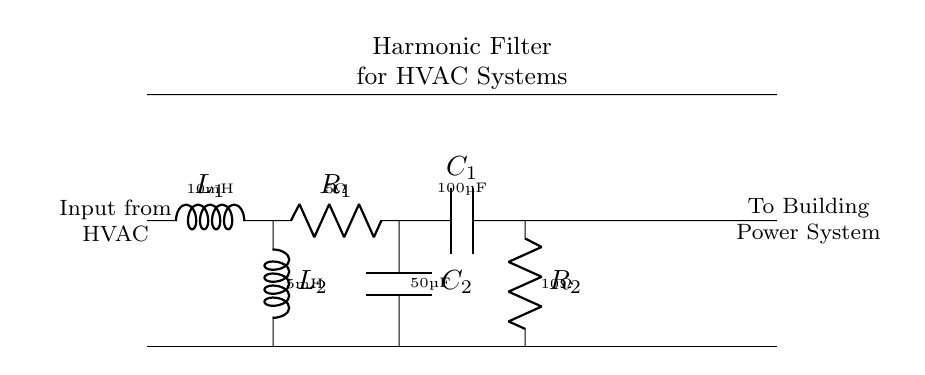What components are in the circuit? The components in the circuit include two inductors, two capacitors, and two resistors. They are labeled as L1, L2, C1, C2, R1, and R2.
Answer: Two inductors, two capacitors, two resistors What is the value of the first capacitor? The value of the first capacitor is indicated next to C1 in the diagram, which is 100 microfarads.
Answer: 100 microfarads Which component is connected to the ground? The components L2, C2, and R2 are connected to the bottom line, which represents the ground in the circuit diagram.
Answer: L2, C2, and R2 What type of circuit is this? This circuit is classified as a harmonic filter circuit, designed to reduce harmonic distortion in HVAC systems.
Answer: Harmonic filter How is the main path connected to the filter? The main path connects to the harmonic filter at L1, and the other side of the filter connects to the building power system. This shows the relationship between the HVAC system input and the filter.
Answer: Through inductor L1 What is the function of R2 in this circuit? R2 serves as a damping resistor in the harmonic filter, helping to control the response of the filter and reduce resonant peaks by dissipating energy.
Answer: Damping resistor 